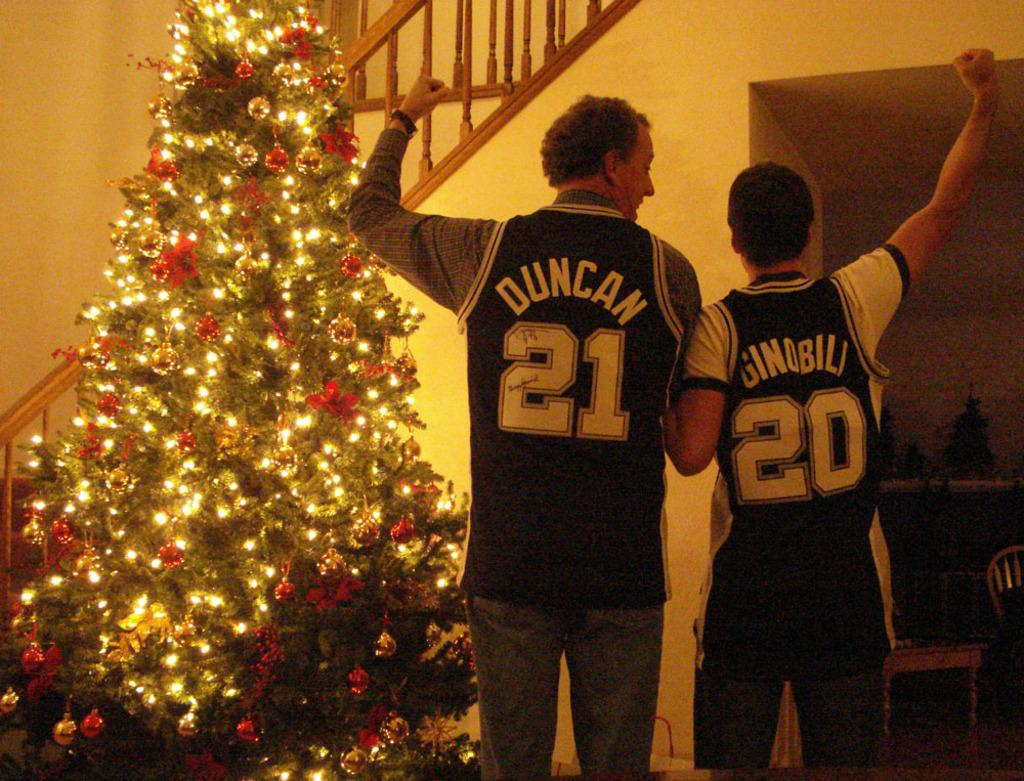How many people are in the image? There are two persons in the image. What can be seen on the shirts of the persons? The persons have names and numbers on their shirts. What is a prominent feature of the image related to a holiday? There is a Christmas tree in the image. What architectural feature is present in the image? There are stairs in the image. What type of furniture is in the image? There is a chair in the image. What objects are on a table in the image? There are objects on a table in the image. What type of apparatus is being used by the persons in the image? There is no apparatus present in the image; the persons are simply standing with names and numbers on their shirts. What type of stove can be seen in the image? There is no stove present in the image. 